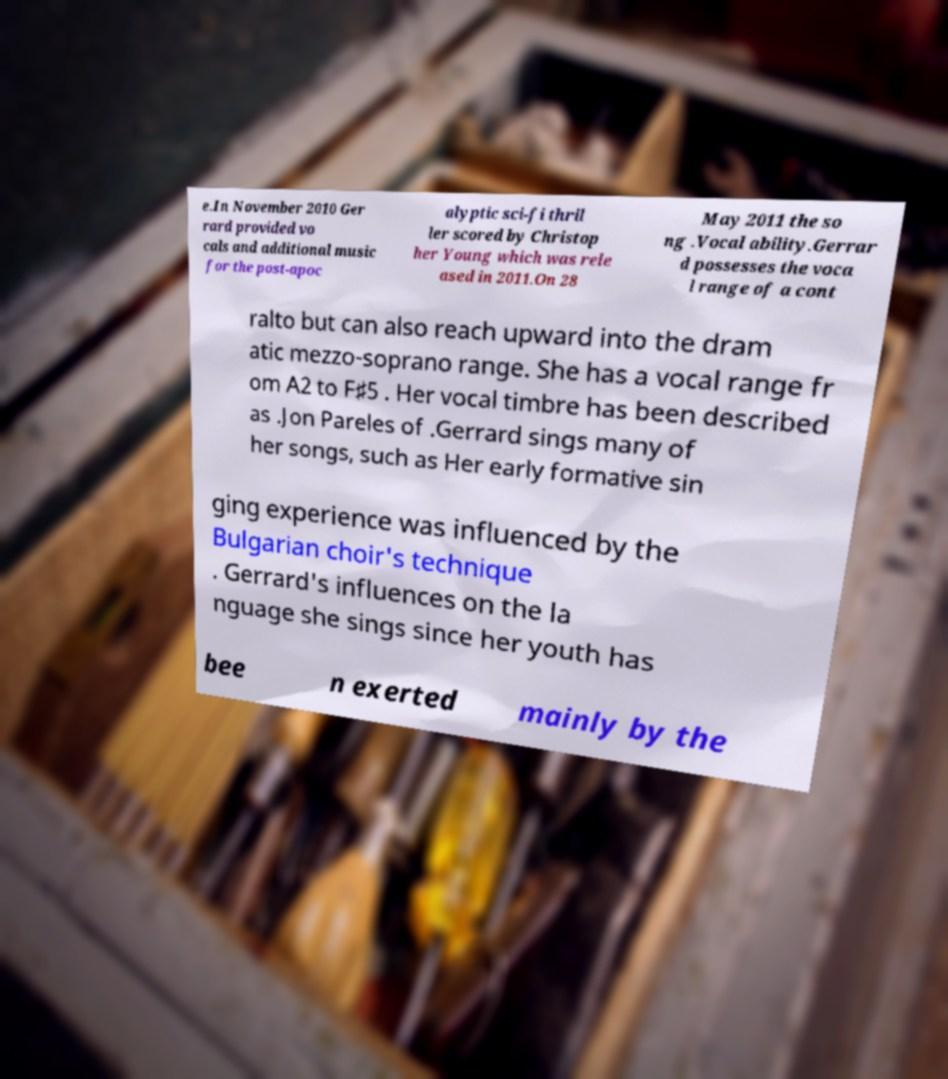Please identify and transcribe the text found in this image. e.In November 2010 Ger rard provided vo cals and additional music for the post-apoc alyptic sci-fi thril ler scored by Christop her Young which was rele ased in 2011.On 28 May 2011 the so ng .Vocal ability.Gerrar d possesses the voca l range of a cont ralto but can also reach upward into the dram atic mezzo-soprano range. She has a vocal range fr om A2 to F♯5 . Her vocal timbre has been described as .Jon Pareles of .Gerrard sings many of her songs, such as Her early formative sin ging experience was influenced by the Bulgarian choir's technique . Gerrard's influences on the la nguage she sings since her youth has bee n exerted mainly by the 